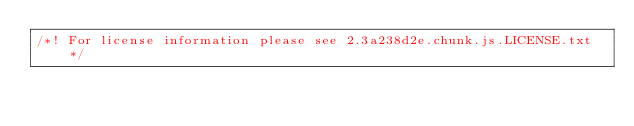Convert code to text. <code><loc_0><loc_0><loc_500><loc_500><_JavaScript_>/*! For license information please see 2.3a238d2e.chunk.js.LICENSE.txt */</code> 